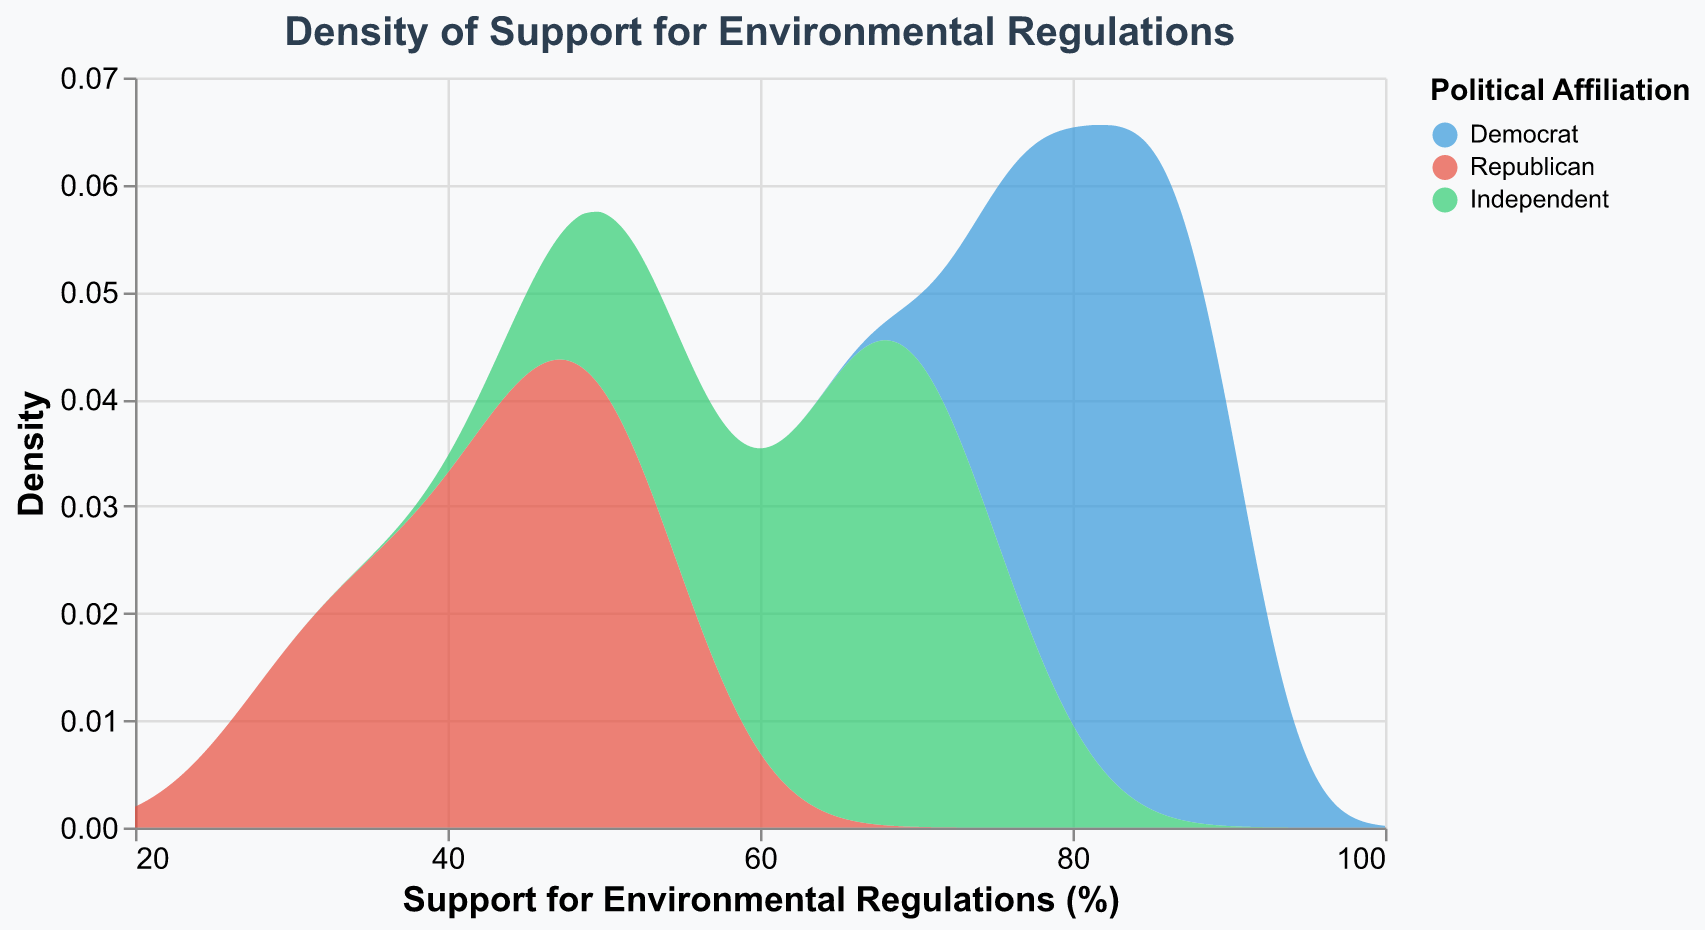What is the title of the plot? The title is shown at the top of the chart and it reads "Density of Support for Environmental Regulations".
Answer: Density of Support for Environmental Regulations What does the x-axis represent in the plot? The x-axis represents "Support for Environmental Regulations (%)", as indicated by the title on the x-axis.
Answer: Support for Environmental Regulations (%) What are the different political affiliations represented in the plot, and how are they color-coded? The plot represents three political affiliations: Democrat (blue), Republican (red), and Independent (green), as indicated in the color legend on the right side of the plot.
Answer: Democrat (blue), Republican (red), Independent (green) Which political affiliation has the highest density peak in the plot? The highest density peak in the plot is for the Democrat group, which reaches the highest point among the color-coded curves.
Answer: Democrat Which region appears to have the lowest support among Republicans based on the density plot? By comparing the distribution of the density curves for each political affiliation, Republicans show lower density values, particularly around the 30-45% range, which is most prominent in the South and Northeast.
Answer: South and Northeast What is the general trend of support for environmental regulations among Independents across different regions? Independents show a wide distribution of support, typically centered around 62-75%%, as seen in the green density curve which peaks and spreads fairly evenly across that range.
Answer: 62-75% How does the distribution of support for environmental regulations among Republicans compare to that among Democrats? Republicans generally have a lower range of support, centering around 30-50%, compared to Democrats, who have a higher range of support, mostly between 75-90% as shown by the red and blue density curves respectively.
Answer: Republicans: 30-50%, Democrats: 75-90% What is the spread of the highest density for Democrats? The Democrat density curve is highest around the 80-90% range of support, indicating that most Democrats have a high level of support for environmental regulations.
Answer: 80-90% Can you identify which political affiliation shows the broadest range of support for environmental regulations? Independents show the broadest range of support for environmental regulations, as their density curve spans from approximately 55% to 75%, while the other groups have more confined ranges.
Answer: Independents Among the Democrats, is the support for environmental regulations more concentrated at a specific support level or dispersed? The density curve for Democrats is more concentrated around 85-90%, indicating that the support among Democrats is highly concentrated at a higher support level.
Answer: Concentrated around 85-90% 